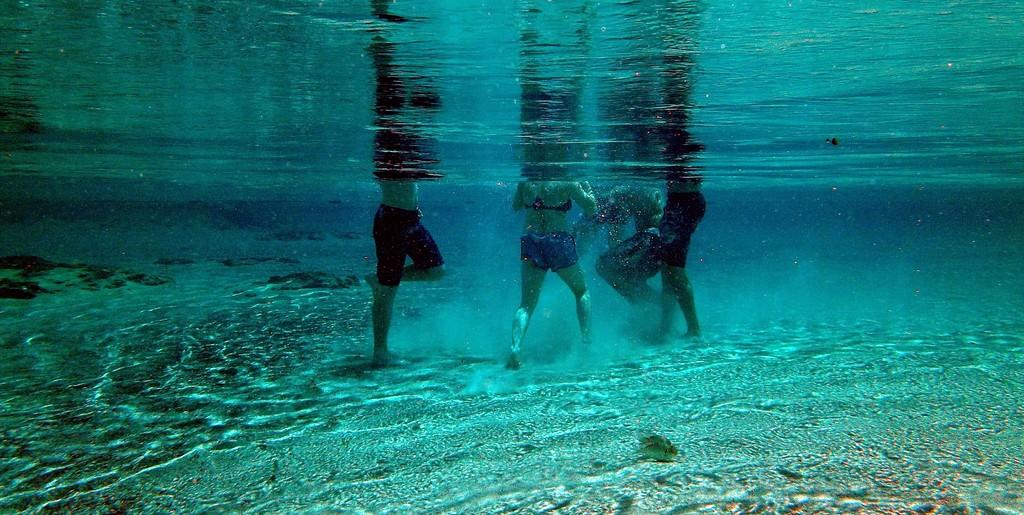Who or what can be seen in the image? There are people in the image. What are the people doing in the image? The people are standing in the water. Can you see a crown on anyone's head in the image? There is no crown visible on anyone's head in the image. What type of cheese is being served in the image? There is no cheese present in the image. 